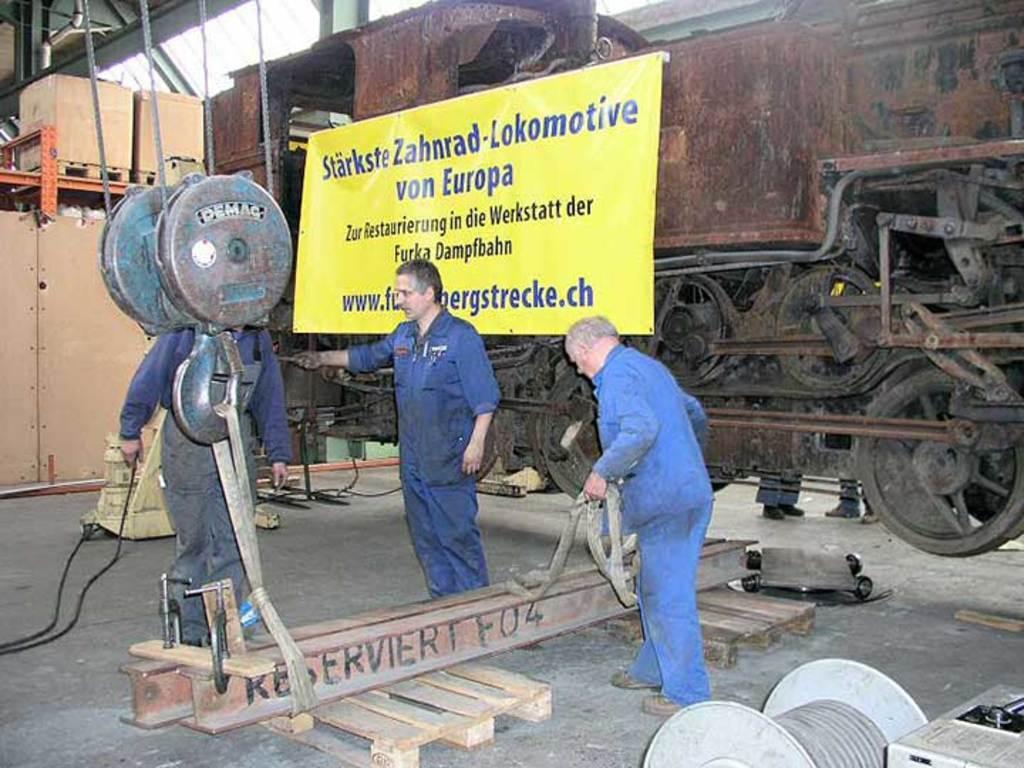Could you give a brief overview of what you see in this image? In this image I can see three persons standing. In front the person is wearing blue color dress and I can see few machines. In the background I can see the banner in yellow color. 